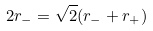<formula> <loc_0><loc_0><loc_500><loc_500>2 r _ { - } = \sqrt { 2 } ( r _ { - } + r _ { + } )</formula> 